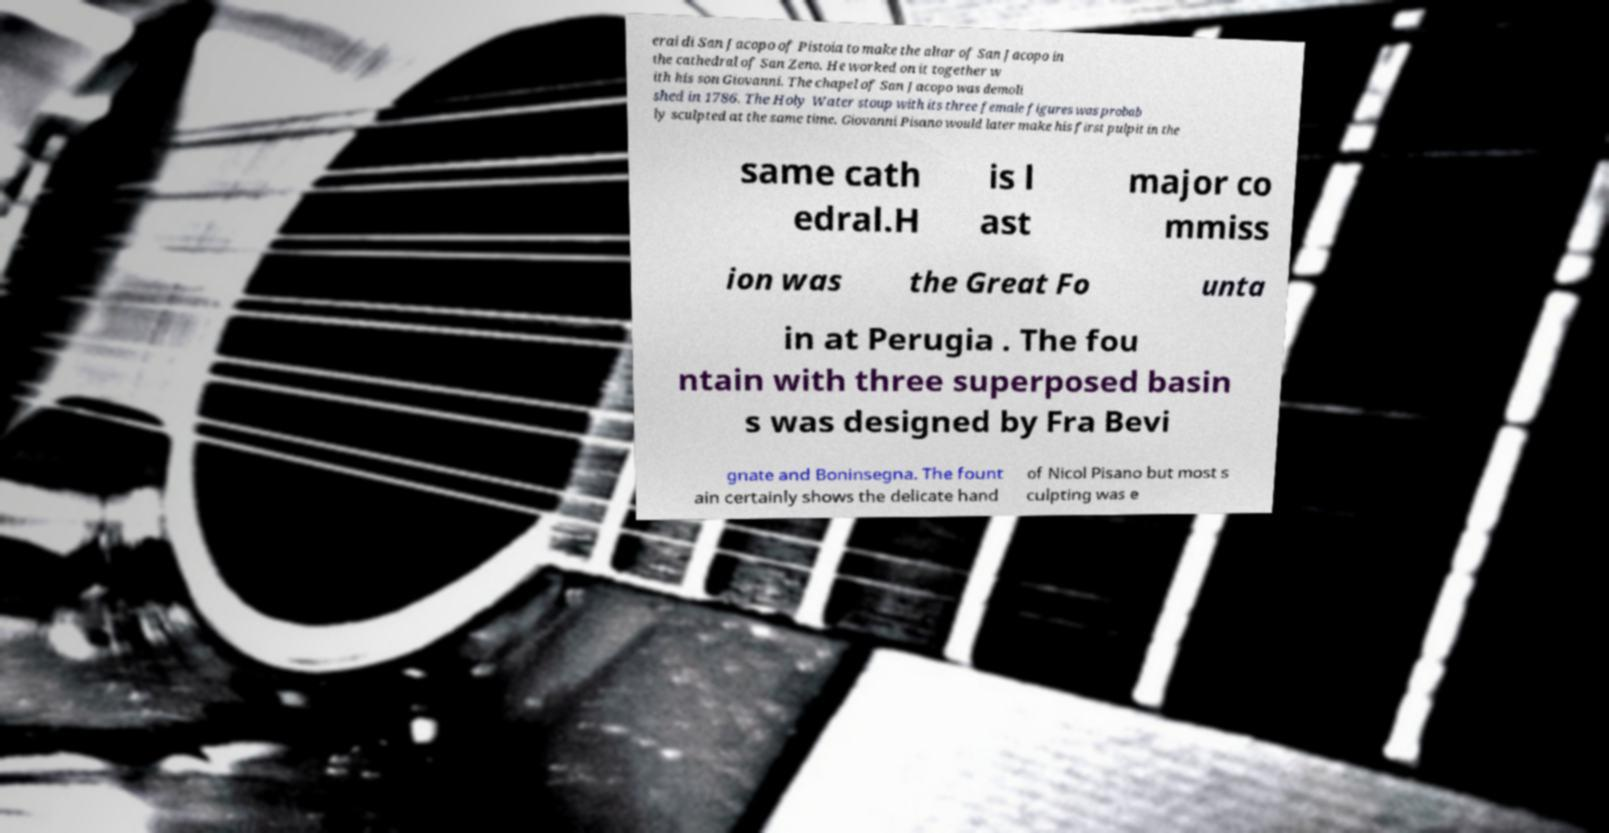For documentation purposes, I need the text within this image transcribed. Could you provide that? erai di San Jacopo of Pistoia to make the altar of San Jacopo in the cathedral of San Zeno. He worked on it together w ith his son Giovanni. The chapel of San Jacopo was demoli shed in 1786. The Holy Water stoup with its three female figures was probab ly sculpted at the same time. Giovanni Pisano would later make his first pulpit in the same cath edral.H is l ast major co mmiss ion was the Great Fo unta in at Perugia . The fou ntain with three superposed basin s was designed by Fra Bevi gnate and Boninsegna. The fount ain certainly shows the delicate hand of Nicol Pisano but most s culpting was e 